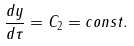Convert formula to latex. <formula><loc_0><loc_0><loc_500><loc_500>\frac { d y } { d \tau } = C _ { 2 } = c o n s t .</formula> 